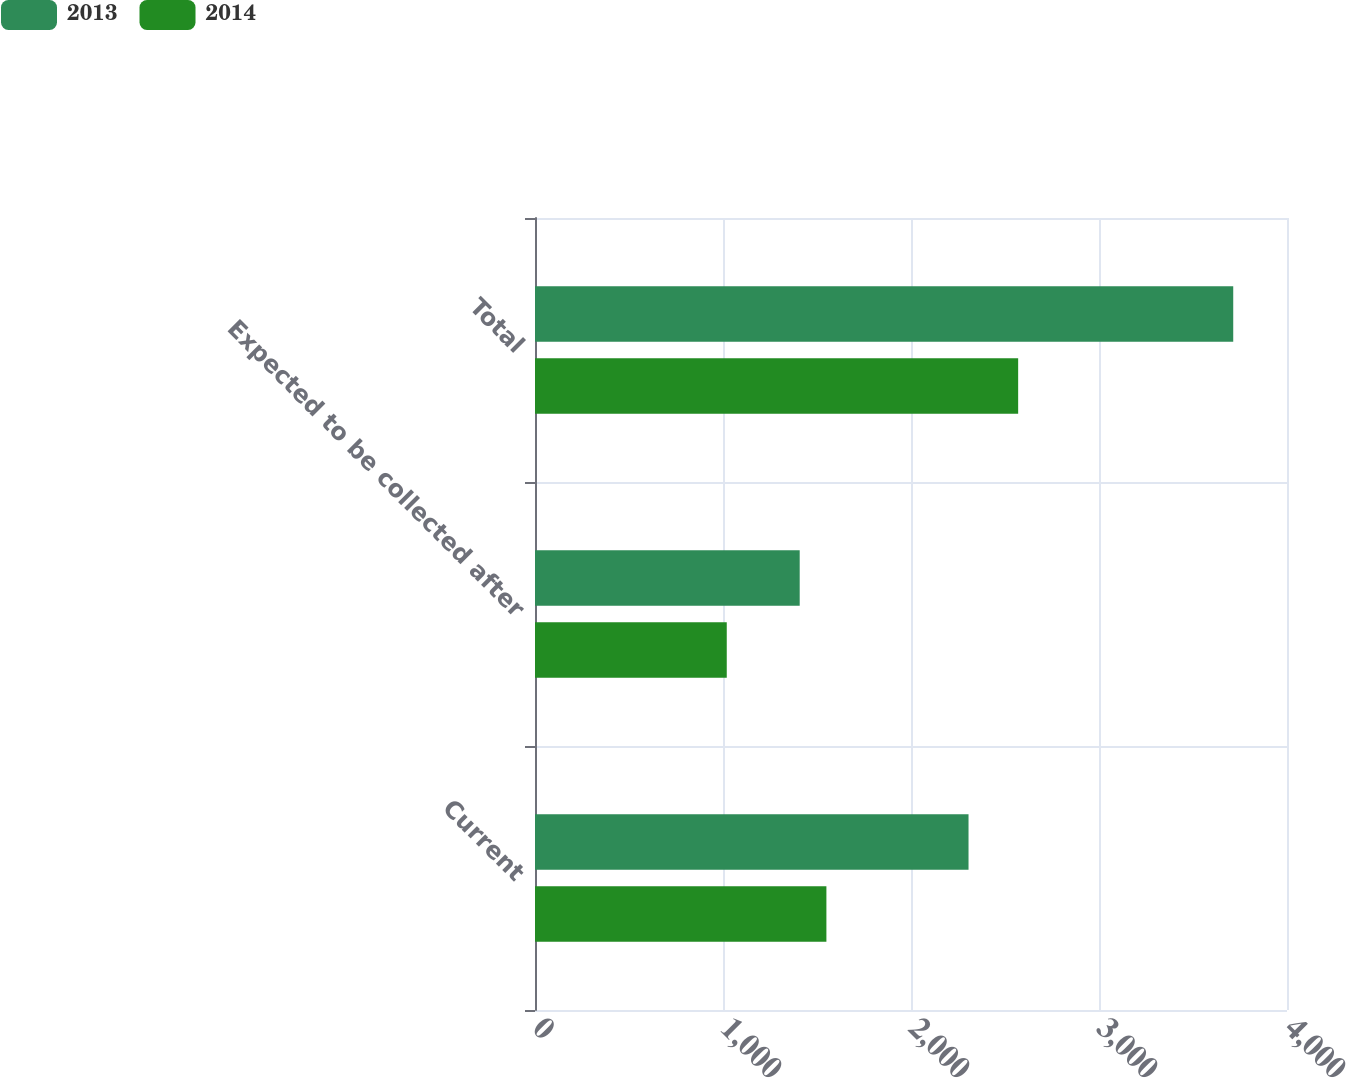Convert chart to OTSL. <chart><loc_0><loc_0><loc_500><loc_500><stacked_bar_chart><ecel><fcel>Current<fcel>Expected to be collected after<fcel>Total<nl><fcel>2013<fcel>2306<fcel>1408<fcel>3714<nl><fcel>2014<fcel>1550<fcel>1020<fcel>2570<nl></chart> 